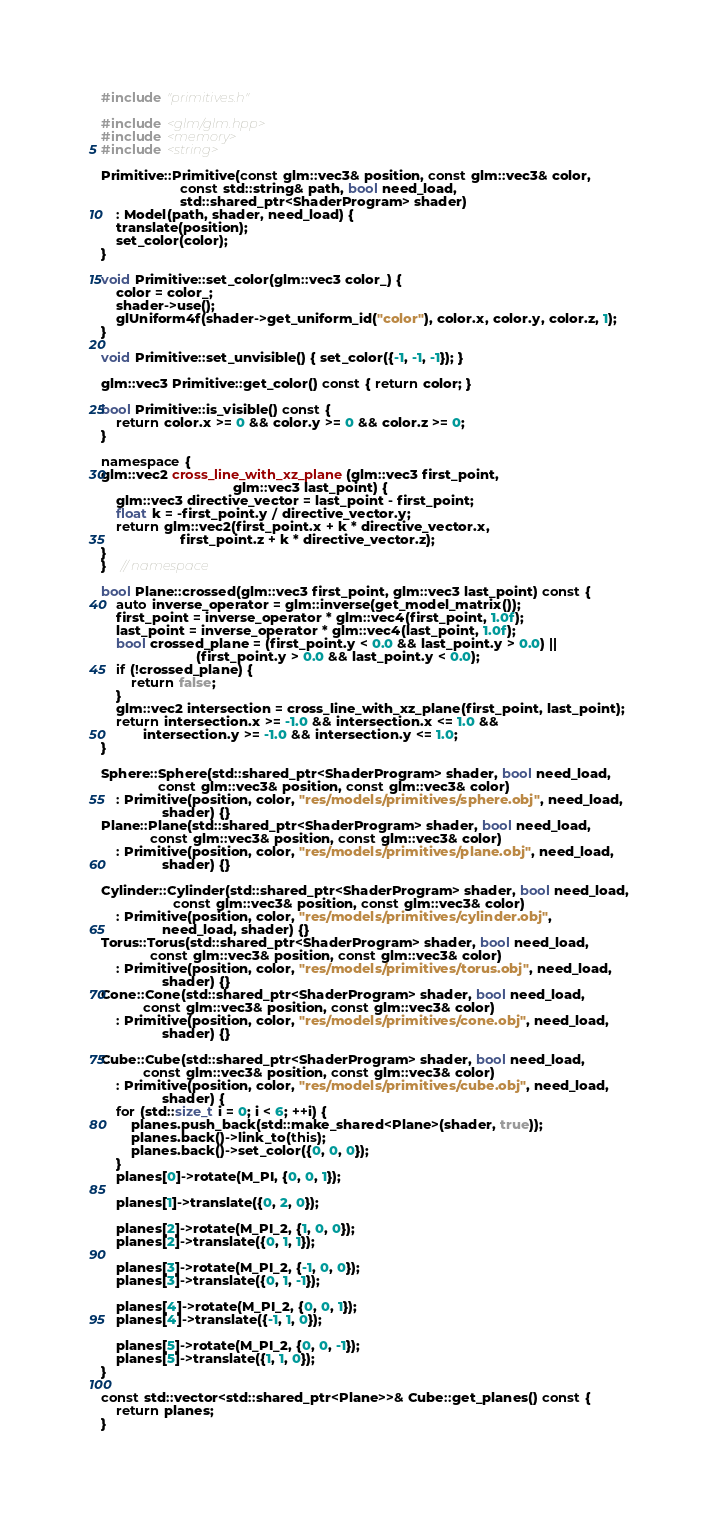<code> <loc_0><loc_0><loc_500><loc_500><_C++_>#include "primitives.h"

#include <glm/glm.hpp>
#include <memory>
#include <string>

Primitive::Primitive(const glm::vec3& position, const glm::vec3& color,
                     const std::string& path, bool need_load,
                     std::shared_ptr<ShaderProgram> shader)
    : Model(path, shader, need_load) {
    translate(position);
    set_color(color);
}

void Primitive::set_color(glm::vec3 color_) {
    color = color_;
    shader->use();
    glUniform4f(shader->get_uniform_id("color"), color.x, color.y, color.z, 1);
}

void Primitive::set_unvisible() { set_color({-1, -1, -1}); }

glm::vec3 Primitive::get_color() const { return color; }

bool Primitive::is_visible() const {
    return color.x >= 0 && color.y >= 0 && color.z >= 0;
}

namespace {
glm::vec2 cross_line_with_xz_plane(glm::vec3 first_point,
                                   glm::vec3 last_point) {
    glm::vec3 directive_vector = last_point - first_point;
    float k = -first_point.y / directive_vector.y;
    return glm::vec2(first_point.x + k * directive_vector.x,
                     first_point.z + k * directive_vector.z);
}
}    // namespace

bool Plane::crossed(glm::vec3 first_point, glm::vec3 last_point) const {
    auto inverse_operator = glm::inverse(get_model_matrix());
    first_point = inverse_operator * glm::vec4(first_point, 1.0f);
    last_point = inverse_operator * glm::vec4(last_point, 1.0f);
    bool crossed_plane = (first_point.y < 0.0 && last_point.y > 0.0) ||
                         (first_point.y > 0.0 && last_point.y < 0.0);
    if (!crossed_plane) {
        return false;
    }
    glm::vec2 intersection = cross_line_with_xz_plane(first_point, last_point);
    return intersection.x >= -1.0 && intersection.x <= 1.0 &&
           intersection.y >= -1.0 && intersection.y <= 1.0;
}

Sphere::Sphere(std::shared_ptr<ShaderProgram> shader, bool need_load,
               const glm::vec3& position, const glm::vec3& color)
    : Primitive(position, color, "res/models/primitives/sphere.obj", need_load,
                shader) {}
Plane::Plane(std::shared_ptr<ShaderProgram> shader, bool need_load,
             const glm::vec3& position, const glm::vec3& color)
    : Primitive(position, color, "res/models/primitives/plane.obj", need_load,
                shader) {}

Cylinder::Cylinder(std::shared_ptr<ShaderProgram> shader, bool need_load,
                   const glm::vec3& position, const glm::vec3& color)
    : Primitive(position, color, "res/models/primitives/cylinder.obj",
                need_load, shader) {}
Torus::Torus(std::shared_ptr<ShaderProgram> shader, bool need_load,
             const glm::vec3& position, const glm::vec3& color)
    : Primitive(position, color, "res/models/primitives/torus.obj", need_load,
                shader) {}
Cone::Cone(std::shared_ptr<ShaderProgram> shader, bool need_load,
           const glm::vec3& position, const glm::vec3& color)
    : Primitive(position, color, "res/models/primitives/cone.obj", need_load,
                shader) {}

Cube::Cube(std::shared_ptr<ShaderProgram> shader, bool need_load,
           const glm::vec3& position, const glm::vec3& color)
    : Primitive(position, color, "res/models/primitives/cube.obj", need_load,
                shader) {
    for (std::size_t i = 0; i < 6; ++i) {
        planes.push_back(std::make_shared<Plane>(shader, true));
        planes.back()->link_to(this);
        planes.back()->set_color({0, 0, 0});
    }
    planes[0]->rotate(M_PI, {0, 0, 1});

    planes[1]->translate({0, 2, 0});

    planes[2]->rotate(M_PI_2, {1, 0, 0});
    planes[2]->translate({0, 1, 1});

    planes[3]->rotate(M_PI_2, {-1, 0, 0});
    planes[3]->translate({0, 1, -1});

    planes[4]->rotate(M_PI_2, {0, 0, 1});
    planes[4]->translate({-1, 1, 0});

    planes[5]->rotate(M_PI_2, {0, 0, -1});
    planes[5]->translate({1, 1, 0});
}

const std::vector<std::shared_ptr<Plane>>& Cube::get_planes() const {
    return planes;
}</code> 